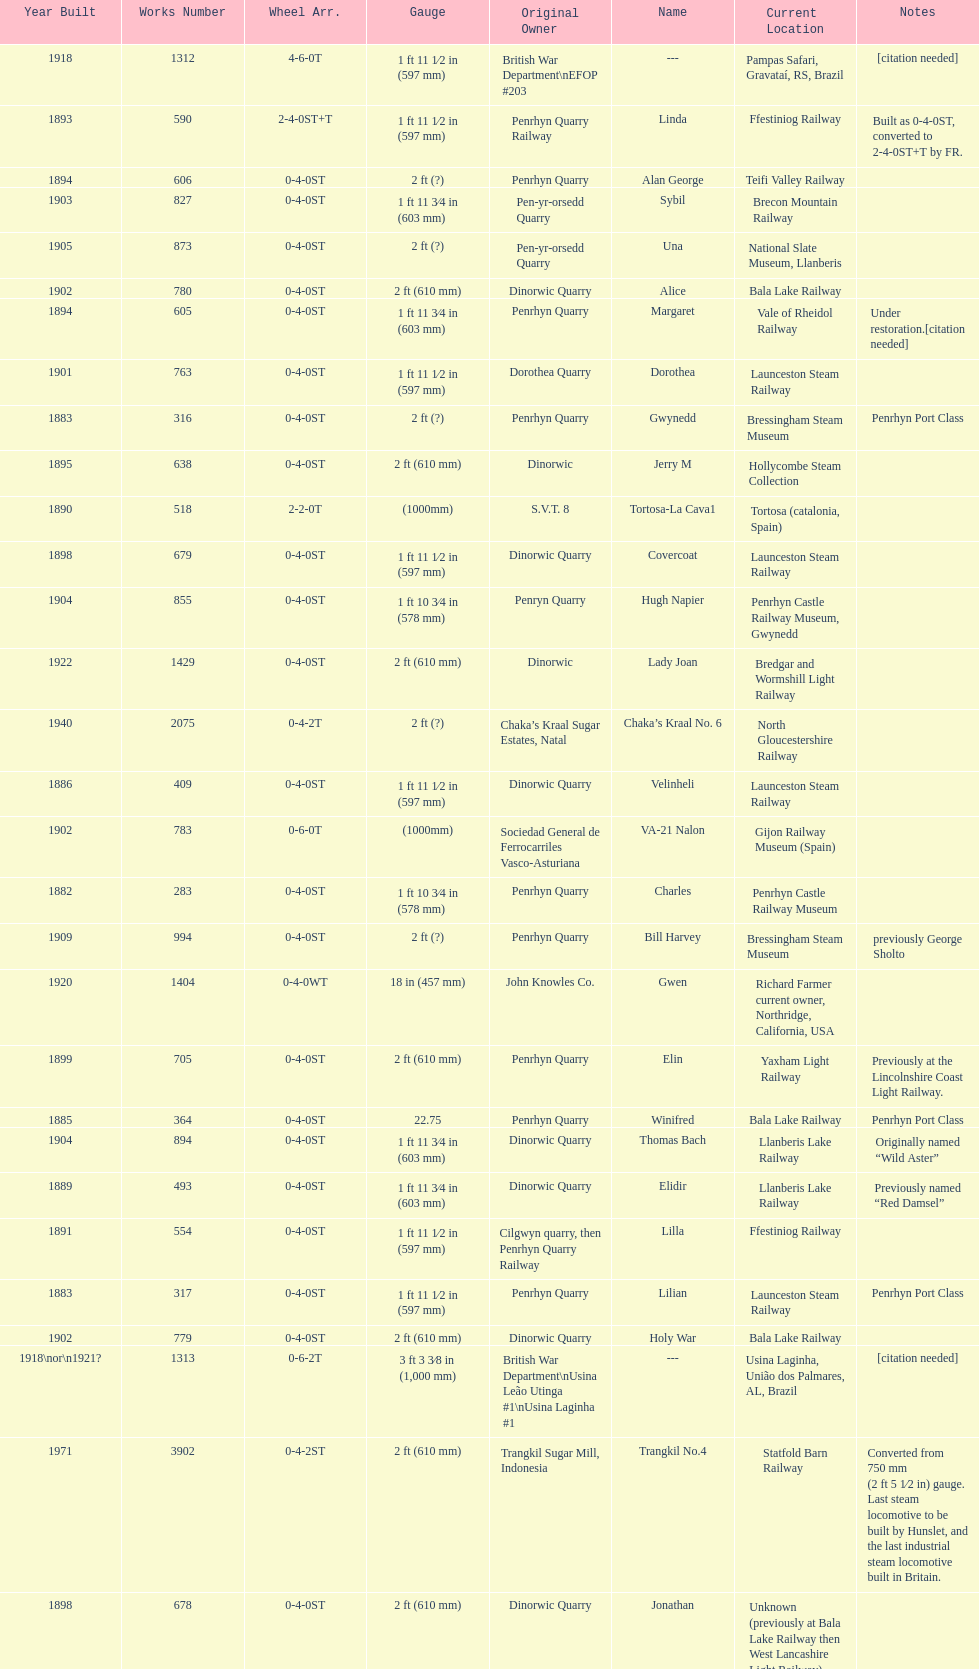After 1940, how many steam locomotives were built? 2. 